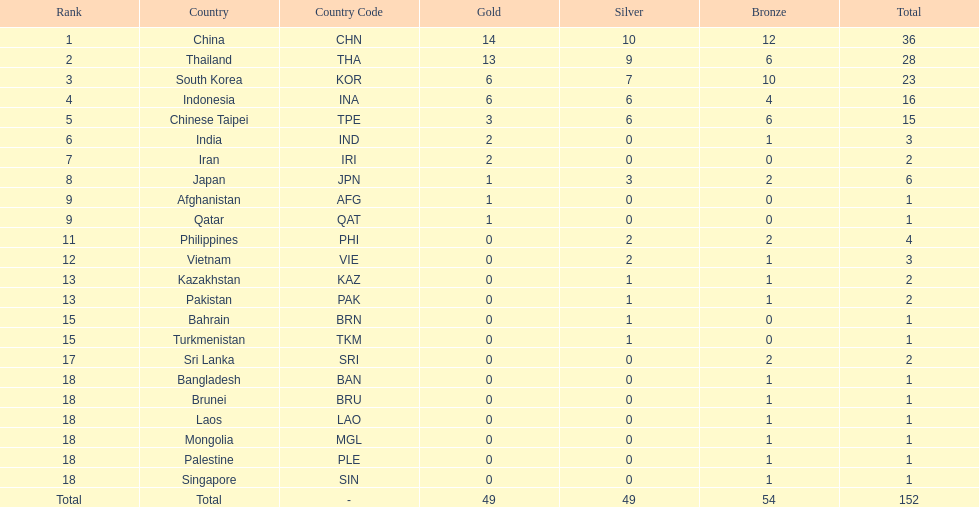How many nations won no silver medals at all? 11. 